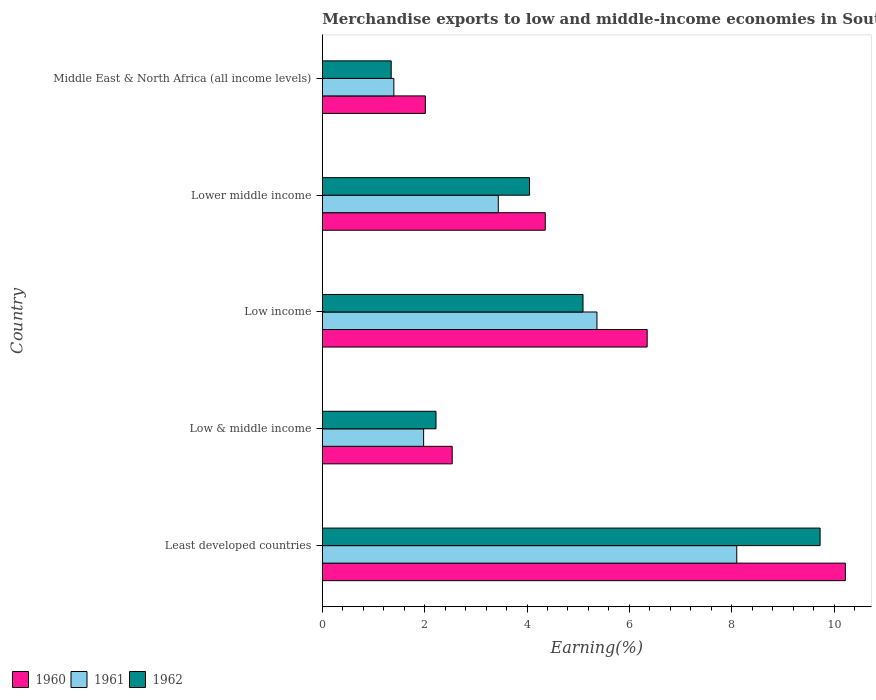How many groups of bars are there?
Your response must be concise. 5. Are the number of bars per tick equal to the number of legend labels?
Give a very brief answer. Yes. In how many cases, is the number of bars for a given country not equal to the number of legend labels?
Provide a short and direct response. 0. What is the percentage of amount earned from merchandise exports in 1961 in Low income?
Keep it short and to the point. 5.37. Across all countries, what is the maximum percentage of amount earned from merchandise exports in 1960?
Your response must be concise. 10.22. Across all countries, what is the minimum percentage of amount earned from merchandise exports in 1961?
Offer a very short reply. 1.4. In which country was the percentage of amount earned from merchandise exports in 1961 maximum?
Your answer should be compact. Least developed countries. In which country was the percentage of amount earned from merchandise exports in 1962 minimum?
Offer a very short reply. Middle East & North Africa (all income levels). What is the total percentage of amount earned from merchandise exports in 1962 in the graph?
Make the answer very short. 22.44. What is the difference between the percentage of amount earned from merchandise exports in 1960 in Low income and that in Middle East & North Africa (all income levels)?
Give a very brief answer. 4.33. What is the difference between the percentage of amount earned from merchandise exports in 1960 in Lower middle income and the percentage of amount earned from merchandise exports in 1961 in Middle East & North Africa (all income levels)?
Ensure brevity in your answer.  2.96. What is the average percentage of amount earned from merchandise exports in 1960 per country?
Provide a succinct answer. 5.09. What is the difference between the percentage of amount earned from merchandise exports in 1960 and percentage of amount earned from merchandise exports in 1962 in Middle East & North Africa (all income levels)?
Your answer should be very brief. 0.67. In how many countries, is the percentage of amount earned from merchandise exports in 1962 greater than 5.6 %?
Your response must be concise. 1. What is the ratio of the percentage of amount earned from merchandise exports in 1962 in Least developed countries to that in Low income?
Your answer should be compact. 1.91. Is the percentage of amount earned from merchandise exports in 1961 in Lower middle income less than that in Middle East & North Africa (all income levels)?
Offer a very short reply. No. What is the difference between the highest and the second highest percentage of amount earned from merchandise exports in 1961?
Offer a very short reply. 2.73. What is the difference between the highest and the lowest percentage of amount earned from merchandise exports in 1962?
Give a very brief answer. 8.38. In how many countries, is the percentage of amount earned from merchandise exports in 1961 greater than the average percentage of amount earned from merchandise exports in 1961 taken over all countries?
Provide a succinct answer. 2. Is the sum of the percentage of amount earned from merchandise exports in 1960 in Lower middle income and Middle East & North Africa (all income levels) greater than the maximum percentage of amount earned from merchandise exports in 1961 across all countries?
Keep it short and to the point. No. What does the 2nd bar from the top in Middle East & North Africa (all income levels) represents?
Offer a terse response. 1961. What does the 1st bar from the bottom in Middle East & North Africa (all income levels) represents?
Give a very brief answer. 1960. Is it the case that in every country, the sum of the percentage of amount earned from merchandise exports in 1960 and percentage of amount earned from merchandise exports in 1961 is greater than the percentage of amount earned from merchandise exports in 1962?
Give a very brief answer. Yes. What is the difference between two consecutive major ticks on the X-axis?
Make the answer very short. 2. Are the values on the major ticks of X-axis written in scientific E-notation?
Provide a succinct answer. No. Does the graph contain grids?
Your response must be concise. No. Where does the legend appear in the graph?
Give a very brief answer. Bottom left. What is the title of the graph?
Provide a succinct answer. Merchandise exports to low and middle-income economies in South Asia. Does "1981" appear as one of the legend labels in the graph?
Ensure brevity in your answer.  No. What is the label or title of the X-axis?
Provide a succinct answer. Earning(%). What is the label or title of the Y-axis?
Ensure brevity in your answer.  Country. What is the Earning(%) in 1960 in Least developed countries?
Ensure brevity in your answer.  10.22. What is the Earning(%) in 1961 in Least developed countries?
Your response must be concise. 8.1. What is the Earning(%) in 1962 in Least developed countries?
Ensure brevity in your answer.  9.73. What is the Earning(%) in 1960 in Low & middle income?
Your answer should be compact. 2.54. What is the Earning(%) in 1961 in Low & middle income?
Provide a short and direct response. 1.98. What is the Earning(%) of 1962 in Low & middle income?
Your answer should be very brief. 2.22. What is the Earning(%) in 1960 in Low income?
Make the answer very short. 6.35. What is the Earning(%) in 1961 in Low income?
Your response must be concise. 5.37. What is the Earning(%) of 1962 in Low income?
Keep it short and to the point. 5.09. What is the Earning(%) in 1960 in Lower middle income?
Your answer should be very brief. 4.36. What is the Earning(%) of 1961 in Lower middle income?
Give a very brief answer. 3.44. What is the Earning(%) of 1962 in Lower middle income?
Provide a succinct answer. 4.05. What is the Earning(%) of 1960 in Middle East & North Africa (all income levels)?
Your answer should be compact. 2.01. What is the Earning(%) in 1961 in Middle East & North Africa (all income levels)?
Provide a succinct answer. 1.4. What is the Earning(%) of 1962 in Middle East & North Africa (all income levels)?
Provide a short and direct response. 1.35. Across all countries, what is the maximum Earning(%) of 1960?
Provide a short and direct response. 10.22. Across all countries, what is the maximum Earning(%) of 1961?
Provide a short and direct response. 8.1. Across all countries, what is the maximum Earning(%) in 1962?
Offer a terse response. 9.73. Across all countries, what is the minimum Earning(%) of 1960?
Your answer should be compact. 2.01. Across all countries, what is the minimum Earning(%) in 1961?
Offer a very short reply. 1.4. Across all countries, what is the minimum Earning(%) of 1962?
Keep it short and to the point. 1.35. What is the total Earning(%) of 1960 in the graph?
Ensure brevity in your answer.  25.47. What is the total Earning(%) in 1961 in the graph?
Offer a very short reply. 20.28. What is the total Earning(%) of 1962 in the graph?
Offer a very short reply. 22.44. What is the difference between the Earning(%) in 1960 in Least developed countries and that in Low & middle income?
Your answer should be very brief. 7.68. What is the difference between the Earning(%) of 1961 in Least developed countries and that in Low & middle income?
Keep it short and to the point. 6.12. What is the difference between the Earning(%) in 1962 in Least developed countries and that in Low & middle income?
Provide a short and direct response. 7.5. What is the difference between the Earning(%) in 1960 in Least developed countries and that in Low income?
Provide a short and direct response. 3.87. What is the difference between the Earning(%) in 1961 in Least developed countries and that in Low income?
Make the answer very short. 2.73. What is the difference between the Earning(%) in 1962 in Least developed countries and that in Low income?
Make the answer very short. 4.63. What is the difference between the Earning(%) of 1960 in Least developed countries and that in Lower middle income?
Provide a succinct answer. 5.86. What is the difference between the Earning(%) in 1961 in Least developed countries and that in Lower middle income?
Make the answer very short. 4.66. What is the difference between the Earning(%) of 1962 in Least developed countries and that in Lower middle income?
Offer a very short reply. 5.68. What is the difference between the Earning(%) of 1960 in Least developed countries and that in Middle East & North Africa (all income levels)?
Your response must be concise. 8.21. What is the difference between the Earning(%) in 1961 in Least developed countries and that in Middle East & North Africa (all income levels)?
Your answer should be compact. 6.7. What is the difference between the Earning(%) of 1962 in Least developed countries and that in Middle East & North Africa (all income levels)?
Offer a very short reply. 8.38. What is the difference between the Earning(%) in 1960 in Low & middle income and that in Low income?
Your response must be concise. -3.81. What is the difference between the Earning(%) of 1961 in Low & middle income and that in Low income?
Provide a succinct answer. -3.39. What is the difference between the Earning(%) of 1962 in Low & middle income and that in Low income?
Your response must be concise. -2.87. What is the difference between the Earning(%) of 1960 in Low & middle income and that in Lower middle income?
Provide a short and direct response. -1.82. What is the difference between the Earning(%) of 1961 in Low & middle income and that in Lower middle income?
Your response must be concise. -1.46. What is the difference between the Earning(%) of 1962 in Low & middle income and that in Lower middle income?
Your answer should be very brief. -1.83. What is the difference between the Earning(%) of 1960 in Low & middle income and that in Middle East & North Africa (all income levels)?
Offer a terse response. 0.52. What is the difference between the Earning(%) in 1961 in Low & middle income and that in Middle East & North Africa (all income levels)?
Your answer should be very brief. 0.58. What is the difference between the Earning(%) in 1962 in Low & middle income and that in Middle East & North Africa (all income levels)?
Your response must be concise. 0.88. What is the difference between the Earning(%) of 1960 in Low income and that in Lower middle income?
Ensure brevity in your answer.  1.99. What is the difference between the Earning(%) in 1961 in Low income and that in Lower middle income?
Keep it short and to the point. 1.93. What is the difference between the Earning(%) of 1962 in Low income and that in Lower middle income?
Your answer should be compact. 1.04. What is the difference between the Earning(%) in 1960 in Low income and that in Middle East & North Africa (all income levels)?
Your response must be concise. 4.33. What is the difference between the Earning(%) in 1961 in Low income and that in Middle East & North Africa (all income levels)?
Ensure brevity in your answer.  3.97. What is the difference between the Earning(%) in 1962 in Low income and that in Middle East & North Africa (all income levels)?
Provide a succinct answer. 3.75. What is the difference between the Earning(%) in 1960 in Lower middle income and that in Middle East & North Africa (all income levels)?
Your answer should be very brief. 2.34. What is the difference between the Earning(%) of 1961 in Lower middle income and that in Middle East & North Africa (all income levels)?
Give a very brief answer. 2.04. What is the difference between the Earning(%) in 1962 in Lower middle income and that in Middle East & North Africa (all income levels)?
Make the answer very short. 2.7. What is the difference between the Earning(%) in 1960 in Least developed countries and the Earning(%) in 1961 in Low & middle income?
Your answer should be very brief. 8.24. What is the difference between the Earning(%) in 1960 in Least developed countries and the Earning(%) in 1962 in Low & middle income?
Give a very brief answer. 8. What is the difference between the Earning(%) in 1961 in Least developed countries and the Earning(%) in 1962 in Low & middle income?
Provide a short and direct response. 5.88. What is the difference between the Earning(%) in 1960 in Least developed countries and the Earning(%) in 1961 in Low income?
Give a very brief answer. 4.85. What is the difference between the Earning(%) in 1960 in Least developed countries and the Earning(%) in 1962 in Low income?
Provide a succinct answer. 5.13. What is the difference between the Earning(%) of 1961 in Least developed countries and the Earning(%) of 1962 in Low income?
Your answer should be compact. 3. What is the difference between the Earning(%) of 1960 in Least developed countries and the Earning(%) of 1961 in Lower middle income?
Make the answer very short. 6.78. What is the difference between the Earning(%) of 1960 in Least developed countries and the Earning(%) of 1962 in Lower middle income?
Ensure brevity in your answer.  6.17. What is the difference between the Earning(%) in 1961 in Least developed countries and the Earning(%) in 1962 in Lower middle income?
Offer a terse response. 4.05. What is the difference between the Earning(%) in 1960 in Least developed countries and the Earning(%) in 1961 in Middle East & North Africa (all income levels)?
Provide a succinct answer. 8.82. What is the difference between the Earning(%) of 1960 in Least developed countries and the Earning(%) of 1962 in Middle East & North Africa (all income levels)?
Offer a terse response. 8.87. What is the difference between the Earning(%) of 1961 in Least developed countries and the Earning(%) of 1962 in Middle East & North Africa (all income levels)?
Provide a short and direct response. 6.75. What is the difference between the Earning(%) in 1960 in Low & middle income and the Earning(%) in 1961 in Low income?
Provide a succinct answer. -2.83. What is the difference between the Earning(%) of 1960 in Low & middle income and the Earning(%) of 1962 in Low income?
Provide a short and direct response. -2.56. What is the difference between the Earning(%) in 1961 in Low & middle income and the Earning(%) in 1962 in Low income?
Give a very brief answer. -3.11. What is the difference between the Earning(%) in 1960 in Low & middle income and the Earning(%) in 1961 in Lower middle income?
Your response must be concise. -0.9. What is the difference between the Earning(%) in 1960 in Low & middle income and the Earning(%) in 1962 in Lower middle income?
Your answer should be very brief. -1.51. What is the difference between the Earning(%) in 1961 in Low & middle income and the Earning(%) in 1962 in Lower middle income?
Ensure brevity in your answer.  -2.07. What is the difference between the Earning(%) of 1960 in Low & middle income and the Earning(%) of 1961 in Middle East & North Africa (all income levels)?
Your answer should be very brief. 1.14. What is the difference between the Earning(%) of 1960 in Low & middle income and the Earning(%) of 1962 in Middle East & North Africa (all income levels)?
Your response must be concise. 1.19. What is the difference between the Earning(%) in 1961 in Low & middle income and the Earning(%) in 1962 in Middle East & North Africa (all income levels)?
Your answer should be compact. 0.63. What is the difference between the Earning(%) of 1960 in Low income and the Earning(%) of 1961 in Lower middle income?
Your answer should be compact. 2.91. What is the difference between the Earning(%) of 1960 in Low income and the Earning(%) of 1962 in Lower middle income?
Provide a succinct answer. 2.3. What is the difference between the Earning(%) in 1961 in Low income and the Earning(%) in 1962 in Lower middle income?
Your answer should be compact. 1.32. What is the difference between the Earning(%) in 1960 in Low income and the Earning(%) in 1961 in Middle East & North Africa (all income levels)?
Your answer should be compact. 4.95. What is the difference between the Earning(%) of 1960 in Low income and the Earning(%) of 1962 in Middle East & North Africa (all income levels)?
Offer a very short reply. 5. What is the difference between the Earning(%) of 1961 in Low income and the Earning(%) of 1962 in Middle East & North Africa (all income levels)?
Keep it short and to the point. 4.02. What is the difference between the Earning(%) of 1960 in Lower middle income and the Earning(%) of 1961 in Middle East & North Africa (all income levels)?
Offer a terse response. 2.96. What is the difference between the Earning(%) of 1960 in Lower middle income and the Earning(%) of 1962 in Middle East & North Africa (all income levels)?
Provide a short and direct response. 3.01. What is the difference between the Earning(%) in 1961 in Lower middle income and the Earning(%) in 1962 in Middle East & North Africa (all income levels)?
Keep it short and to the point. 2.09. What is the average Earning(%) of 1960 per country?
Keep it short and to the point. 5.09. What is the average Earning(%) in 1961 per country?
Provide a succinct answer. 4.06. What is the average Earning(%) in 1962 per country?
Offer a terse response. 4.49. What is the difference between the Earning(%) of 1960 and Earning(%) of 1961 in Least developed countries?
Keep it short and to the point. 2.12. What is the difference between the Earning(%) of 1960 and Earning(%) of 1962 in Least developed countries?
Offer a terse response. 0.49. What is the difference between the Earning(%) of 1961 and Earning(%) of 1962 in Least developed countries?
Offer a very short reply. -1.63. What is the difference between the Earning(%) of 1960 and Earning(%) of 1961 in Low & middle income?
Provide a succinct answer. 0.56. What is the difference between the Earning(%) in 1960 and Earning(%) in 1962 in Low & middle income?
Provide a succinct answer. 0.32. What is the difference between the Earning(%) in 1961 and Earning(%) in 1962 in Low & middle income?
Provide a succinct answer. -0.24. What is the difference between the Earning(%) in 1960 and Earning(%) in 1961 in Low income?
Offer a terse response. 0.98. What is the difference between the Earning(%) in 1960 and Earning(%) in 1962 in Low income?
Offer a terse response. 1.25. What is the difference between the Earning(%) of 1961 and Earning(%) of 1962 in Low income?
Provide a succinct answer. 0.27. What is the difference between the Earning(%) of 1960 and Earning(%) of 1961 in Lower middle income?
Offer a very short reply. 0.92. What is the difference between the Earning(%) of 1960 and Earning(%) of 1962 in Lower middle income?
Keep it short and to the point. 0.31. What is the difference between the Earning(%) of 1961 and Earning(%) of 1962 in Lower middle income?
Offer a very short reply. -0.61. What is the difference between the Earning(%) of 1960 and Earning(%) of 1961 in Middle East & North Africa (all income levels)?
Provide a succinct answer. 0.62. What is the difference between the Earning(%) of 1960 and Earning(%) of 1962 in Middle East & North Africa (all income levels)?
Offer a terse response. 0.67. What is the difference between the Earning(%) of 1961 and Earning(%) of 1962 in Middle East & North Africa (all income levels)?
Your answer should be compact. 0.05. What is the ratio of the Earning(%) in 1960 in Least developed countries to that in Low & middle income?
Your answer should be very brief. 4.03. What is the ratio of the Earning(%) of 1961 in Least developed countries to that in Low & middle income?
Offer a very short reply. 4.09. What is the ratio of the Earning(%) of 1962 in Least developed countries to that in Low & middle income?
Give a very brief answer. 4.38. What is the ratio of the Earning(%) in 1960 in Least developed countries to that in Low income?
Offer a terse response. 1.61. What is the ratio of the Earning(%) of 1961 in Least developed countries to that in Low income?
Your response must be concise. 1.51. What is the ratio of the Earning(%) in 1962 in Least developed countries to that in Low income?
Give a very brief answer. 1.91. What is the ratio of the Earning(%) in 1960 in Least developed countries to that in Lower middle income?
Offer a terse response. 2.35. What is the ratio of the Earning(%) in 1961 in Least developed countries to that in Lower middle income?
Offer a terse response. 2.36. What is the ratio of the Earning(%) in 1962 in Least developed countries to that in Lower middle income?
Provide a short and direct response. 2.4. What is the ratio of the Earning(%) in 1960 in Least developed countries to that in Middle East & North Africa (all income levels)?
Offer a terse response. 5.08. What is the ratio of the Earning(%) of 1961 in Least developed countries to that in Middle East & North Africa (all income levels)?
Your response must be concise. 5.79. What is the ratio of the Earning(%) of 1962 in Least developed countries to that in Middle East & North Africa (all income levels)?
Provide a succinct answer. 7.23. What is the ratio of the Earning(%) of 1960 in Low & middle income to that in Low income?
Provide a short and direct response. 0.4. What is the ratio of the Earning(%) in 1961 in Low & middle income to that in Low income?
Make the answer very short. 0.37. What is the ratio of the Earning(%) in 1962 in Low & middle income to that in Low income?
Provide a succinct answer. 0.44. What is the ratio of the Earning(%) in 1960 in Low & middle income to that in Lower middle income?
Offer a very short reply. 0.58. What is the ratio of the Earning(%) of 1961 in Low & middle income to that in Lower middle income?
Give a very brief answer. 0.58. What is the ratio of the Earning(%) in 1962 in Low & middle income to that in Lower middle income?
Offer a terse response. 0.55. What is the ratio of the Earning(%) in 1960 in Low & middle income to that in Middle East & North Africa (all income levels)?
Offer a terse response. 1.26. What is the ratio of the Earning(%) in 1961 in Low & middle income to that in Middle East & North Africa (all income levels)?
Make the answer very short. 1.42. What is the ratio of the Earning(%) in 1962 in Low & middle income to that in Middle East & North Africa (all income levels)?
Make the answer very short. 1.65. What is the ratio of the Earning(%) in 1960 in Low income to that in Lower middle income?
Make the answer very short. 1.46. What is the ratio of the Earning(%) of 1961 in Low income to that in Lower middle income?
Keep it short and to the point. 1.56. What is the ratio of the Earning(%) in 1962 in Low income to that in Lower middle income?
Provide a short and direct response. 1.26. What is the ratio of the Earning(%) of 1960 in Low income to that in Middle East & North Africa (all income levels)?
Ensure brevity in your answer.  3.15. What is the ratio of the Earning(%) in 1961 in Low income to that in Middle East & North Africa (all income levels)?
Your answer should be very brief. 3.84. What is the ratio of the Earning(%) in 1962 in Low income to that in Middle East & North Africa (all income levels)?
Provide a short and direct response. 3.78. What is the ratio of the Earning(%) in 1960 in Lower middle income to that in Middle East & North Africa (all income levels)?
Your answer should be compact. 2.16. What is the ratio of the Earning(%) of 1961 in Lower middle income to that in Middle East & North Africa (all income levels)?
Make the answer very short. 2.46. What is the ratio of the Earning(%) of 1962 in Lower middle income to that in Middle East & North Africa (all income levels)?
Provide a short and direct response. 3.01. What is the difference between the highest and the second highest Earning(%) in 1960?
Ensure brevity in your answer.  3.87. What is the difference between the highest and the second highest Earning(%) of 1961?
Give a very brief answer. 2.73. What is the difference between the highest and the second highest Earning(%) of 1962?
Your response must be concise. 4.63. What is the difference between the highest and the lowest Earning(%) in 1960?
Your response must be concise. 8.21. What is the difference between the highest and the lowest Earning(%) in 1961?
Make the answer very short. 6.7. What is the difference between the highest and the lowest Earning(%) of 1962?
Provide a short and direct response. 8.38. 